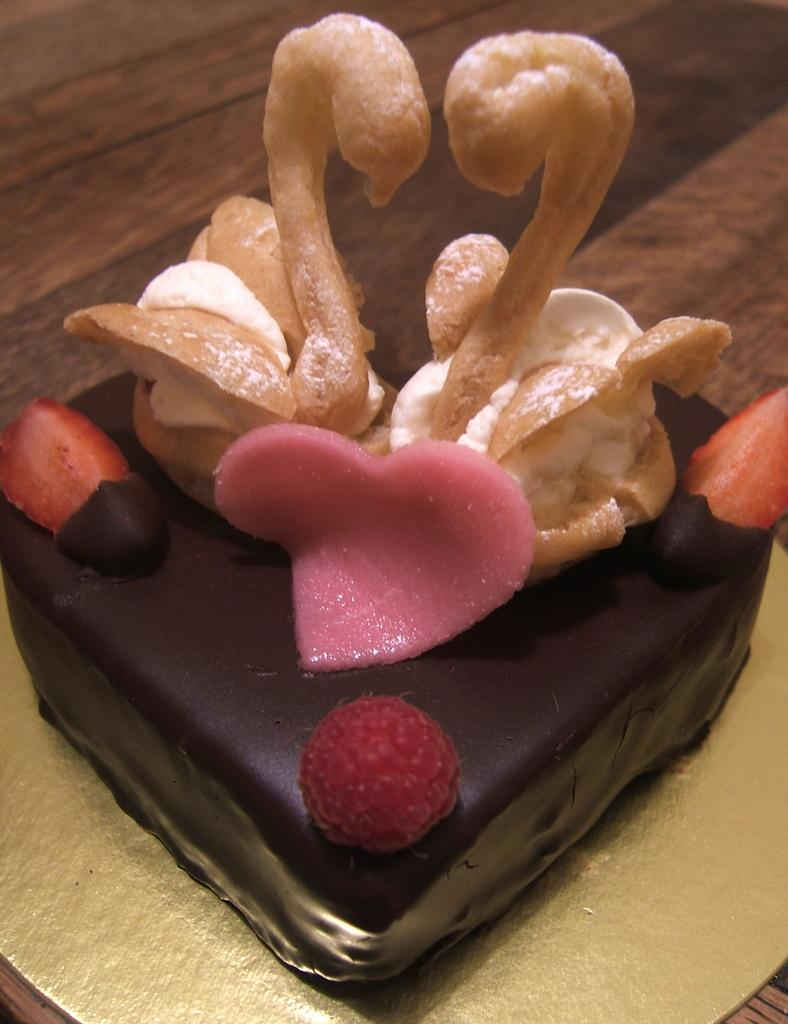What type of cake is visible in the image? There is a chocolate cake in the image. Where is the chocolate cake located? The chocolate cake is kept on the floor. What type of trick can be seen being performed with the balls in the image? There are no balls or tricks present in the image; it only features a chocolate cake on the floor. 